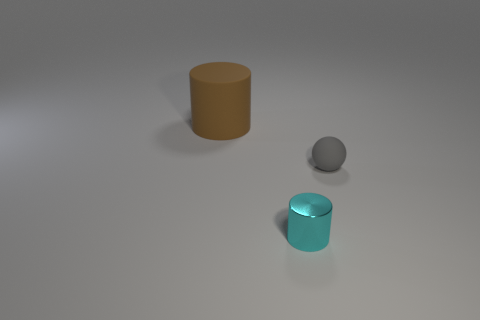Add 3 tiny metal objects. How many objects exist? 6 Subtract all spheres. How many objects are left? 2 Subtract 0 yellow balls. How many objects are left? 3 Subtract all small gray things. Subtract all big brown things. How many objects are left? 1 Add 1 small matte spheres. How many small matte spheres are left? 2 Add 2 small gray matte objects. How many small gray matte objects exist? 3 